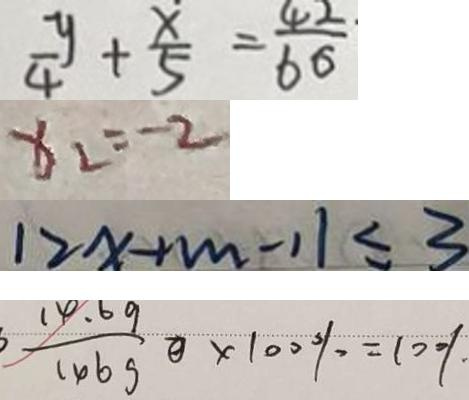Convert formula to latex. <formula><loc_0><loc_0><loc_500><loc_500>\frac { y } { 4 } + \frac { x } { 5 } = \frac { 4 2 } { 6 6 } 
 x _ { 2 } = - 2 
 1 2 x + m - 1 1 \leq 3 
 \frac { 1 4 . 6 9 } { 1 4 6 9 } ) \times 1 0 0 \% = 1 0 0 、 %</formula> 